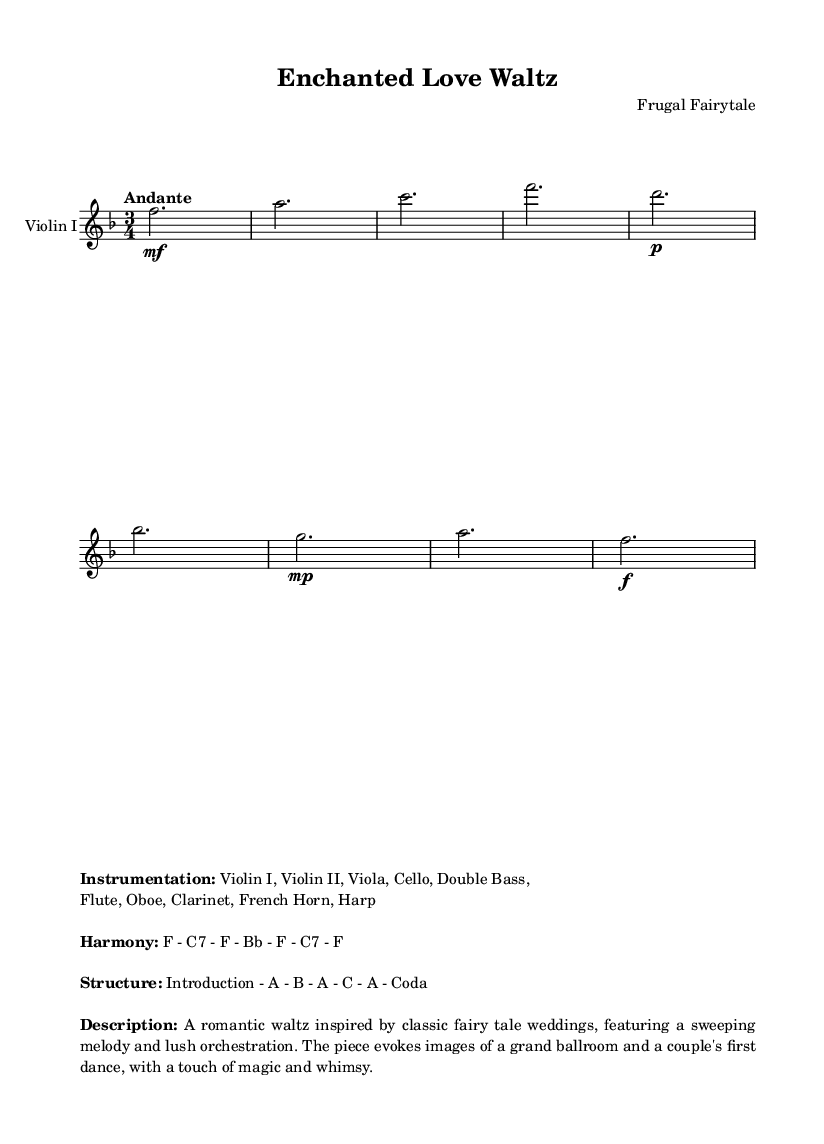What is the key signature of this music? The key signature indicated in the music is F major, which has one flat (B flat).
Answer: F major What is the time signature of this music? The time signature is in 3/4, which means there are three beats in each measure and the quarter note gets one beat.
Answer: 3/4 What is the tempo marking for this piece? The tempo marking presented in the music score is "Andante," which suggests a moderately slow tempo.
Answer: Andante How many sections are in the structure of this piece? The structure of the piece is annotated as "Introduction - A - B - A - C - A - Coda," indicating there are five distinct sections (A, B, C, Coda) along with the introduction.
Answer: Five What is the instrumentation for this score? The score lists the following instruments: Violin I, Violin II, Viola, Cello, Double Bass, Flute, Oboe, Clarinet, French Horn, Harp, which totals ten instruments.
Answer: Ten instruments What is the harmony progression for this piece? The harmony progression indicated in the score is F - C7 - F - Bb - F - C7 - F, showing a specific sequence of chords used throughout.
Answer: F - C7 - F - Bb - F - C7 - F What mood or imagery does this piece evoke? The description states that the piece evokes images of a grand ballroom and a couple's first dance, highlighting a romantic, magical, and whimsical atmosphere suitable for a fairy tale wedding.
Answer: Grand ballroom and first dance 